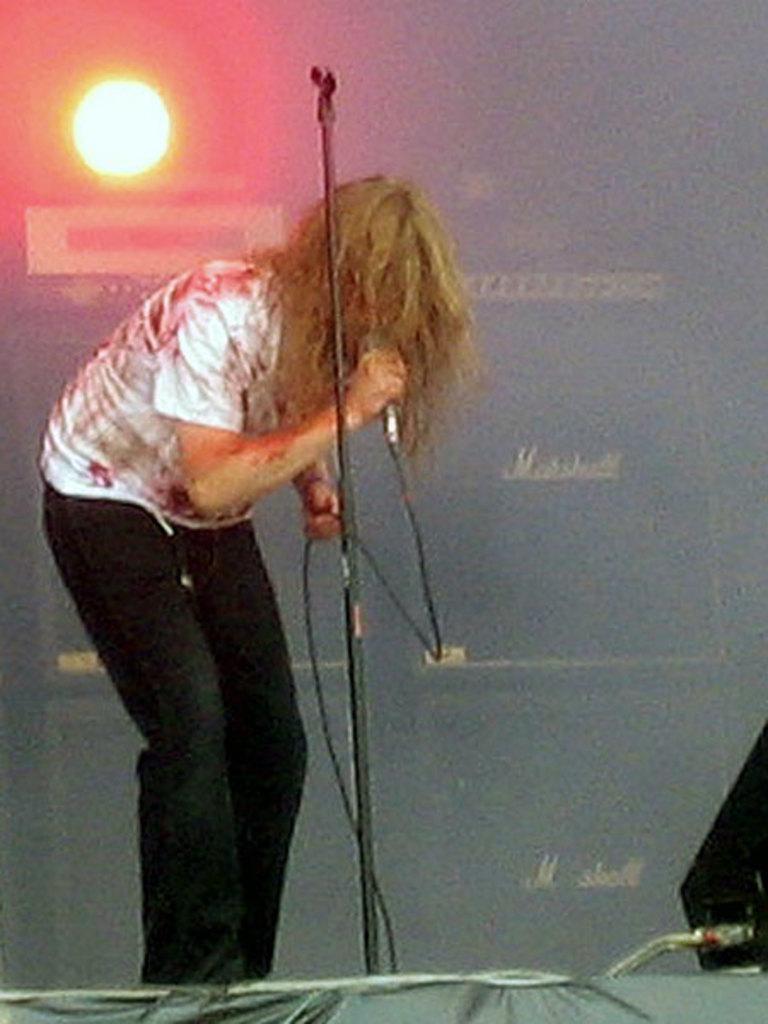Can you describe this image briefly? In this picture we can see a person holding a microphone in hand. There is a stand. We can see a loudspeaker on the right side. There is a light and a text in the background. 